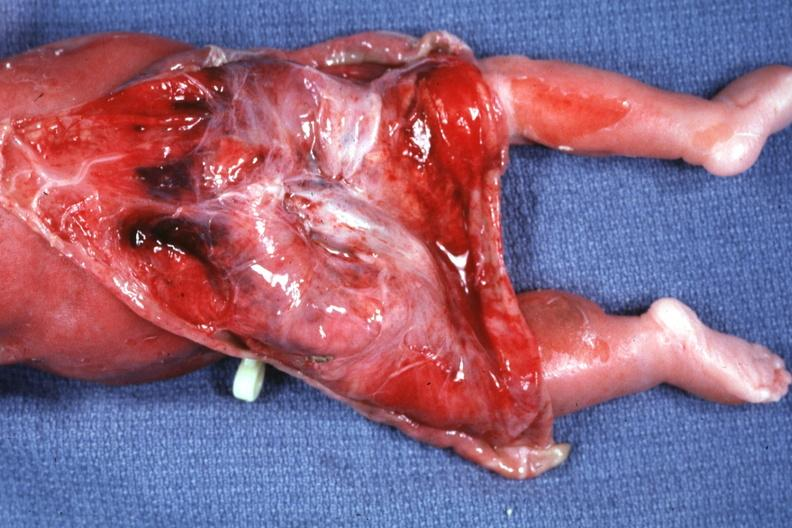s digits reflected to show large tumor mass?
Answer the question using a single word or phrase. No 